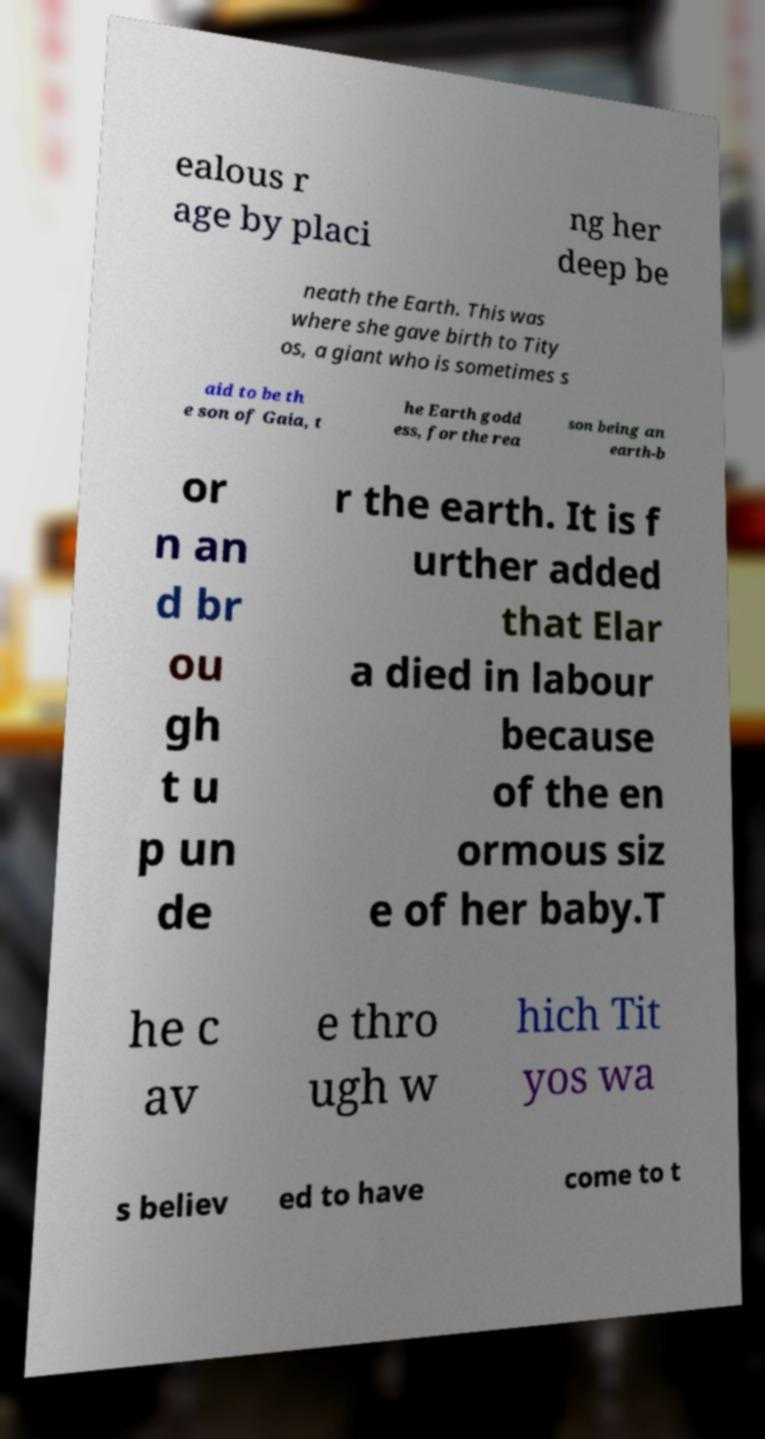I need the written content from this picture converted into text. Can you do that? ealous r age by placi ng her deep be neath the Earth. This was where she gave birth to Tity os, a giant who is sometimes s aid to be th e son of Gaia, t he Earth godd ess, for the rea son being an earth-b or n an d br ou gh t u p un de r the earth. It is f urther added that Elar a died in labour because of the en ormous siz e of her baby.T he c av e thro ugh w hich Tit yos wa s believ ed to have come to t 